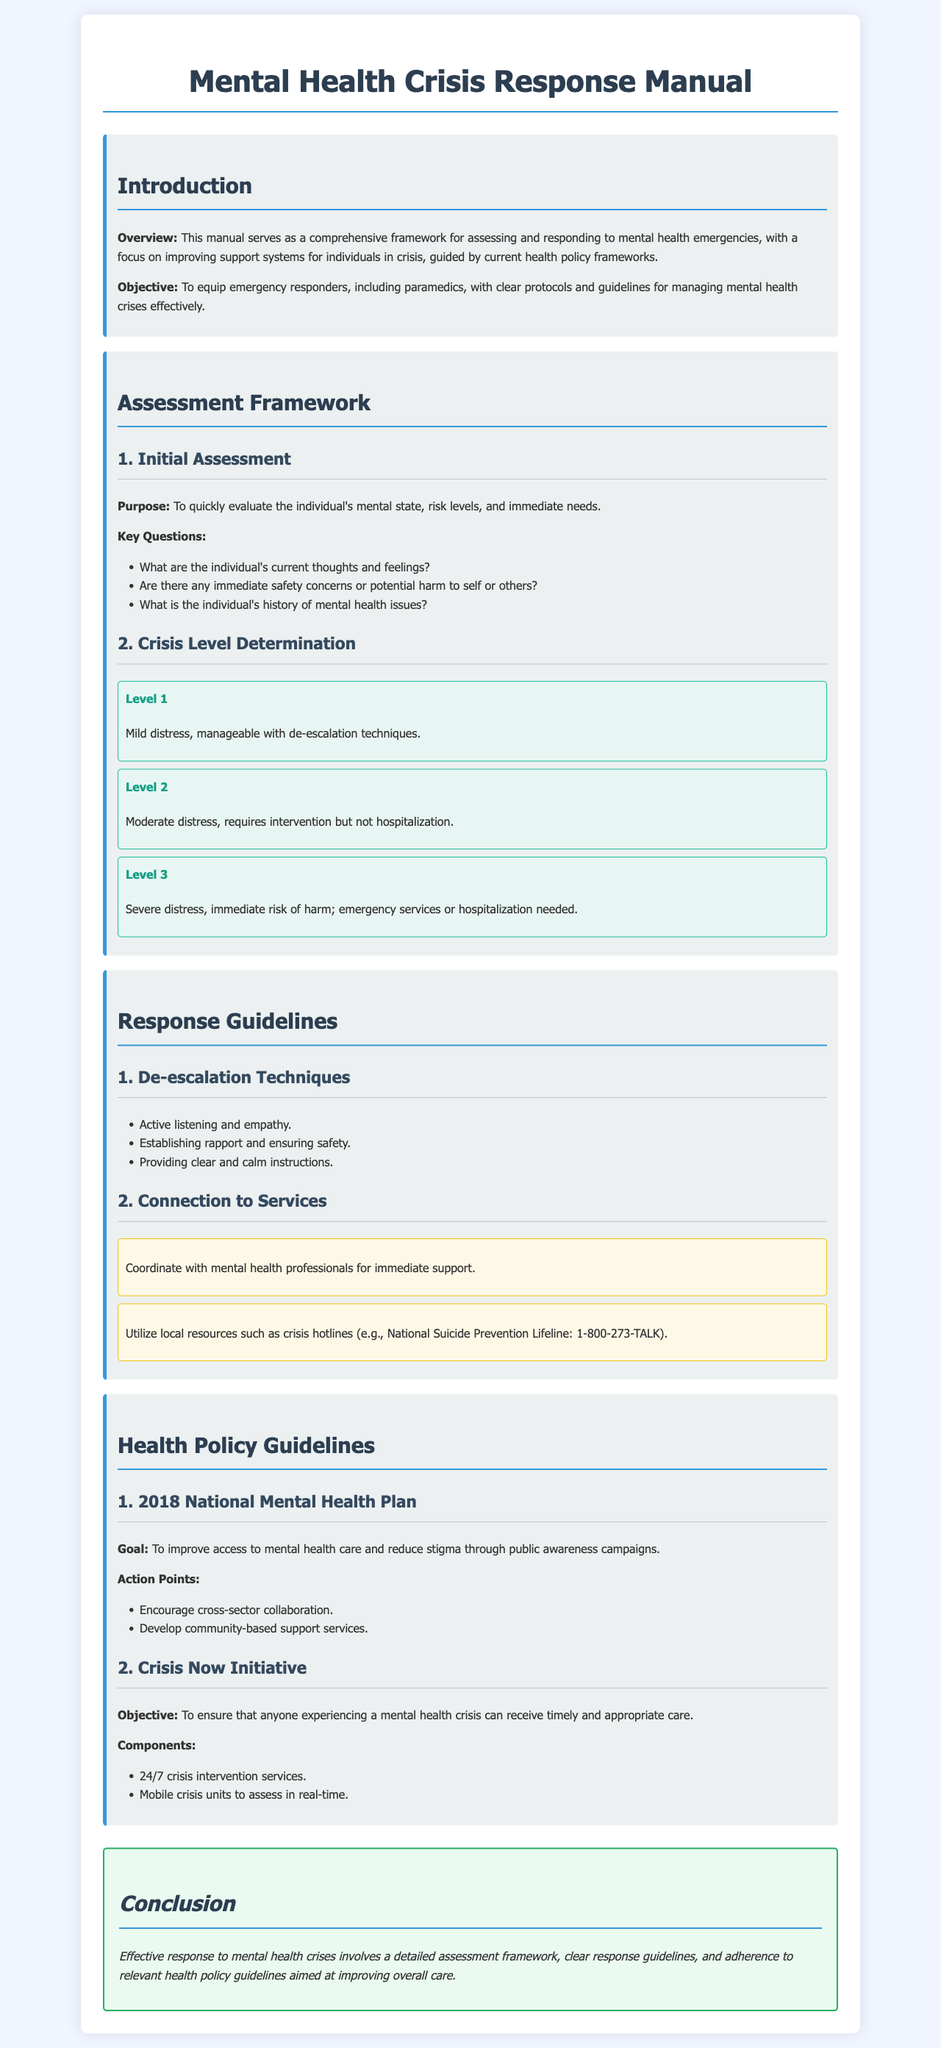What is the main objective of the manual? The manual's objective is to equip emergency responders, including paramedics, with clear protocols and guidelines for managing mental health crises effectively.
Answer: To equip emergency responders with clear protocols What is the first key question during the initial assessment? The first key question focuses on evaluating the individual's current thoughts and feelings.
Answer: What are the individual's current thoughts and feelings? What are the three crisis levels defined in the document? The crisis levels are defined as: Level 1 (Mild distress), Level 2 (Moderate distress), Level 3 (Severe distress).
Answer: Level 1, Level 2, Level 3 What is one component of the Crisis Now Initiative? The Crisis Now Initiative includes 24/7 crisis intervention services as a component.
Answer: 24/7 crisis intervention services What year was the National Mental Health Plan established? The National Mental Health Plan was established in 2018.
Answer: 2018 What action point is encouraged in the National Mental Health Plan? The action point encourages cross-sector collaboration.
Answer: Cross-sector collaboration What type of techniques are recommended for de-escalation? The document recommends techniques like active listening and empathy for de-escalation.
Answer: Active listening and empathy What is the purpose of the assessment framework? The purpose of the assessment framework is to quickly evaluate the individual's mental state, risk levels, and immediate needs.
Answer: To quickly evaluate the individual's mental state 